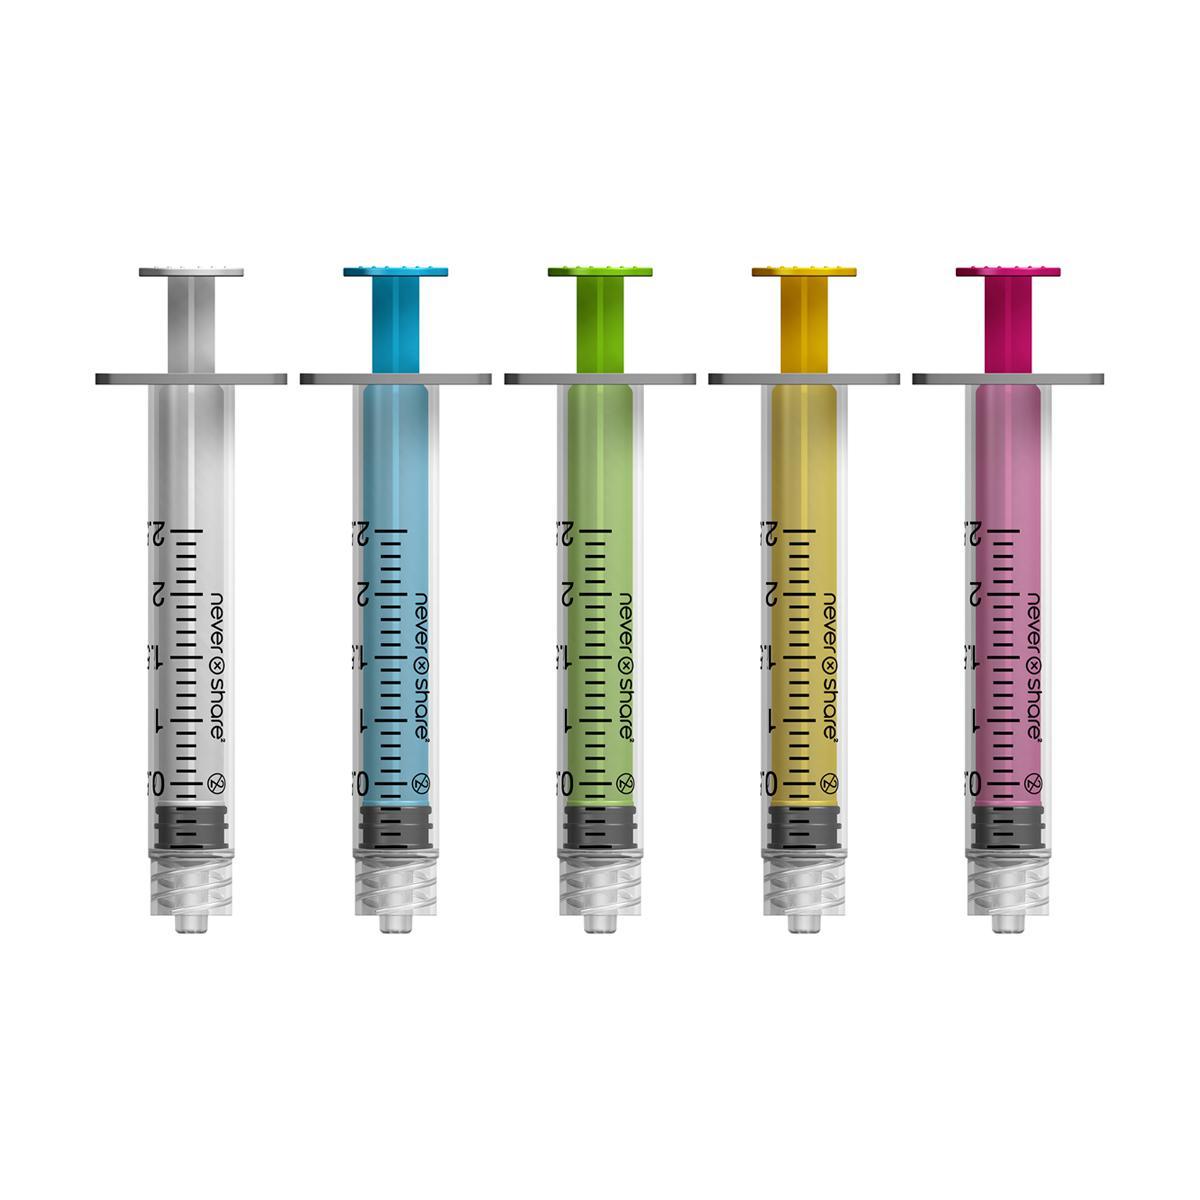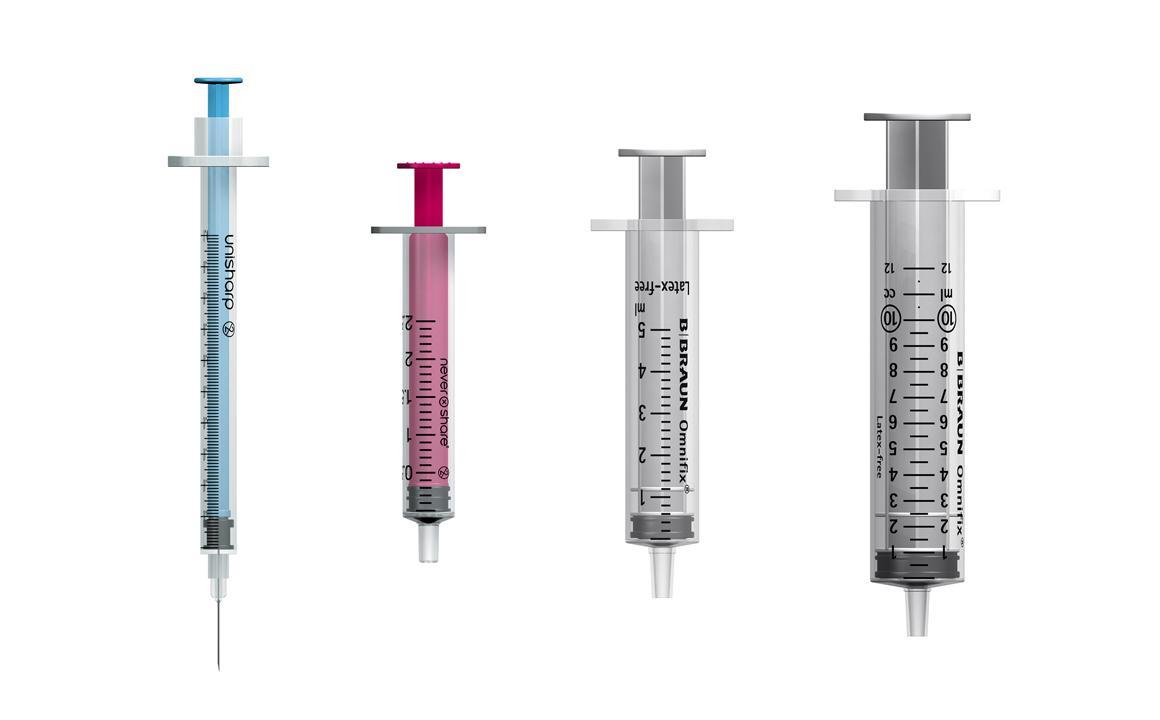The first image is the image on the left, the second image is the image on the right. Assess this claim about the two images: "The left image is a row of needless syringes pointed downward.". Correct or not? Answer yes or no. Yes. The first image is the image on the left, the second image is the image on the right. Evaluate the accuracy of this statement regarding the images: "The left and right image contains a total of nine syringes.". Is it true? Answer yes or no. Yes. 